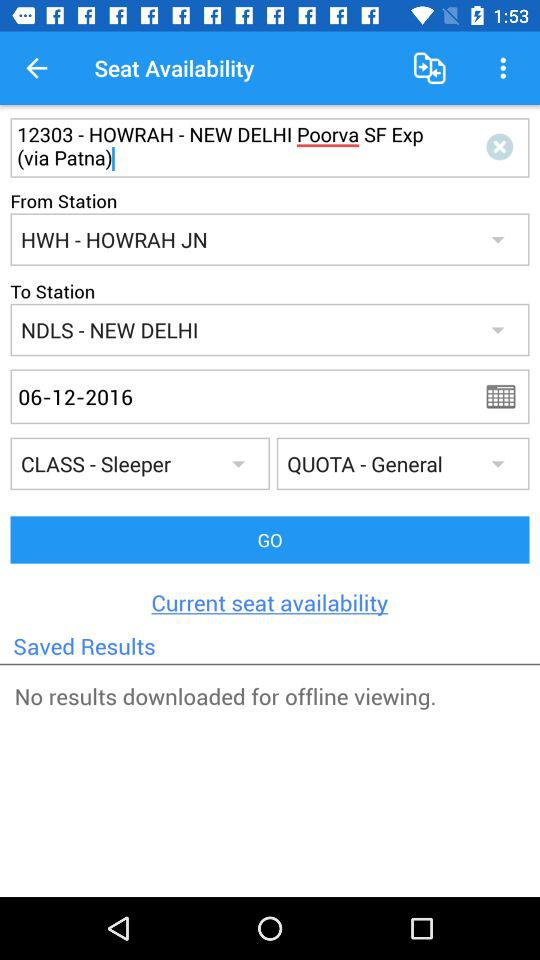What is the reservation date for the train? The reservation date for the train is June 12, 2016. 